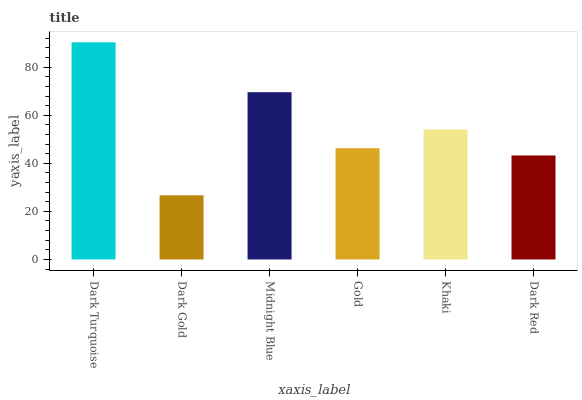Is Dark Gold the minimum?
Answer yes or no. Yes. Is Dark Turquoise the maximum?
Answer yes or no. Yes. Is Midnight Blue the minimum?
Answer yes or no. No. Is Midnight Blue the maximum?
Answer yes or no. No. Is Midnight Blue greater than Dark Gold?
Answer yes or no. Yes. Is Dark Gold less than Midnight Blue?
Answer yes or no. Yes. Is Dark Gold greater than Midnight Blue?
Answer yes or no. No. Is Midnight Blue less than Dark Gold?
Answer yes or no. No. Is Khaki the high median?
Answer yes or no. Yes. Is Gold the low median?
Answer yes or no. Yes. Is Dark Gold the high median?
Answer yes or no. No. Is Dark Red the low median?
Answer yes or no. No. 